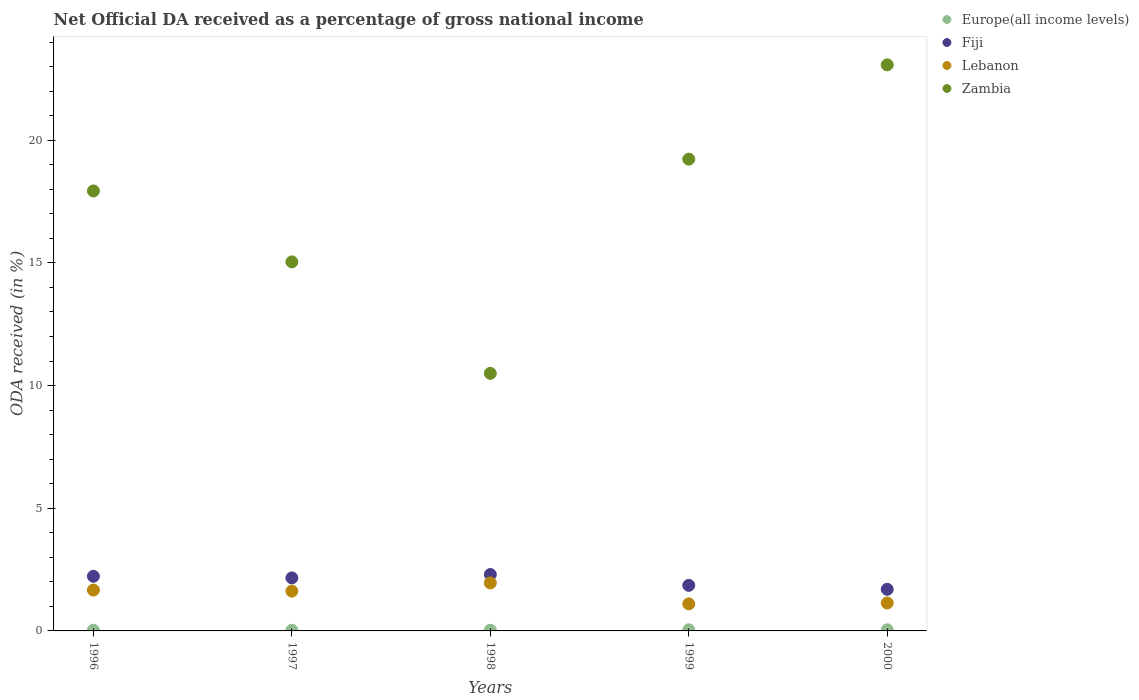How many different coloured dotlines are there?
Your answer should be very brief. 4. Is the number of dotlines equal to the number of legend labels?
Keep it short and to the point. Yes. What is the net official DA received in Fiji in 1999?
Offer a very short reply. 1.86. Across all years, what is the maximum net official DA received in Fiji?
Provide a short and direct response. 2.3. Across all years, what is the minimum net official DA received in Zambia?
Make the answer very short. 10.5. In which year was the net official DA received in Fiji maximum?
Ensure brevity in your answer.  1998. In which year was the net official DA received in Lebanon minimum?
Offer a very short reply. 1999. What is the total net official DA received in Europe(all income levels) in the graph?
Your response must be concise. 0.18. What is the difference between the net official DA received in Fiji in 1996 and that in 1997?
Make the answer very short. 0.07. What is the difference between the net official DA received in Fiji in 1998 and the net official DA received in Lebanon in 2000?
Keep it short and to the point. 1.16. What is the average net official DA received in Lebanon per year?
Make the answer very short. 1.5. In the year 1999, what is the difference between the net official DA received in Zambia and net official DA received in Lebanon?
Provide a short and direct response. 18.12. What is the ratio of the net official DA received in Fiji in 1996 to that in 1997?
Offer a very short reply. 1.03. Is the net official DA received in Zambia in 1996 less than that in 1997?
Give a very brief answer. No. Is the difference between the net official DA received in Zambia in 1997 and 2000 greater than the difference between the net official DA received in Lebanon in 1997 and 2000?
Your answer should be very brief. No. What is the difference between the highest and the second highest net official DA received in Fiji?
Provide a succinct answer. 0.07. What is the difference between the highest and the lowest net official DA received in Europe(all income levels)?
Ensure brevity in your answer.  0.02. Is the sum of the net official DA received in Zambia in 1996 and 2000 greater than the maximum net official DA received in Fiji across all years?
Provide a succinct answer. Yes. Is the net official DA received in Lebanon strictly greater than the net official DA received in Europe(all income levels) over the years?
Keep it short and to the point. Yes. Is the net official DA received in Fiji strictly less than the net official DA received in Zambia over the years?
Give a very brief answer. Yes. How many dotlines are there?
Offer a very short reply. 4. How many years are there in the graph?
Offer a terse response. 5. What is the difference between two consecutive major ticks on the Y-axis?
Offer a terse response. 5. Does the graph contain any zero values?
Ensure brevity in your answer.  No. Where does the legend appear in the graph?
Offer a terse response. Top right. How many legend labels are there?
Make the answer very short. 4. What is the title of the graph?
Make the answer very short. Net Official DA received as a percentage of gross national income. What is the label or title of the Y-axis?
Your answer should be compact. ODA received (in %). What is the ODA received (in %) of Europe(all income levels) in 1996?
Make the answer very short. 0.03. What is the ODA received (in %) in Fiji in 1996?
Your response must be concise. 2.23. What is the ODA received (in %) of Lebanon in 1996?
Your answer should be compact. 1.67. What is the ODA received (in %) in Zambia in 1996?
Give a very brief answer. 17.93. What is the ODA received (in %) of Europe(all income levels) in 1997?
Ensure brevity in your answer.  0.03. What is the ODA received (in %) of Fiji in 1997?
Provide a succinct answer. 2.16. What is the ODA received (in %) of Lebanon in 1997?
Offer a terse response. 1.62. What is the ODA received (in %) of Zambia in 1997?
Give a very brief answer. 15.04. What is the ODA received (in %) of Europe(all income levels) in 1998?
Ensure brevity in your answer.  0.03. What is the ODA received (in %) in Fiji in 1998?
Your answer should be compact. 2.3. What is the ODA received (in %) in Lebanon in 1998?
Your answer should be very brief. 1.96. What is the ODA received (in %) in Zambia in 1998?
Make the answer very short. 10.5. What is the ODA received (in %) in Europe(all income levels) in 1999?
Your answer should be very brief. 0.05. What is the ODA received (in %) in Fiji in 1999?
Give a very brief answer. 1.86. What is the ODA received (in %) of Lebanon in 1999?
Provide a succinct answer. 1.1. What is the ODA received (in %) in Zambia in 1999?
Your response must be concise. 19.23. What is the ODA received (in %) in Europe(all income levels) in 2000?
Your answer should be very brief. 0.05. What is the ODA received (in %) in Fiji in 2000?
Offer a very short reply. 1.7. What is the ODA received (in %) in Lebanon in 2000?
Ensure brevity in your answer.  1.14. What is the ODA received (in %) of Zambia in 2000?
Provide a short and direct response. 23.07. Across all years, what is the maximum ODA received (in %) of Europe(all income levels)?
Your answer should be very brief. 0.05. Across all years, what is the maximum ODA received (in %) in Fiji?
Provide a short and direct response. 2.3. Across all years, what is the maximum ODA received (in %) in Lebanon?
Provide a short and direct response. 1.96. Across all years, what is the maximum ODA received (in %) in Zambia?
Your answer should be compact. 23.07. Across all years, what is the minimum ODA received (in %) in Europe(all income levels)?
Provide a short and direct response. 0.03. Across all years, what is the minimum ODA received (in %) in Fiji?
Your response must be concise. 1.7. Across all years, what is the minimum ODA received (in %) of Lebanon?
Provide a succinct answer. 1.1. Across all years, what is the minimum ODA received (in %) in Zambia?
Your answer should be very brief. 10.5. What is the total ODA received (in %) in Europe(all income levels) in the graph?
Ensure brevity in your answer.  0.18. What is the total ODA received (in %) of Fiji in the graph?
Provide a short and direct response. 10.24. What is the total ODA received (in %) in Lebanon in the graph?
Your answer should be compact. 7.48. What is the total ODA received (in %) of Zambia in the graph?
Offer a very short reply. 85.76. What is the difference between the ODA received (in %) in Europe(all income levels) in 1996 and that in 1997?
Your response must be concise. 0. What is the difference between the ODA received (in %) of Fiji in 1996 and that in 1997?
Keep it short and to the point. 0.07. What is the difference between the ODA received (in %) in Lebanon in 1996 and that in 1997?
Keep it short and to the point. 0.04. What is the difference between the ODA received (in %) of Zambia in 1996 and that in 1997?
Provide a succinct answer. 2.89. What is the difference between the ODA received (in %) of Europe(all income levels) in 1996 and that in 1998?
Offer a terse response. 0. What is the difference between the ODA received (in %) in Fiji in 1996 and that in 1998?
Your answer should be very brief. -0.07. What is the difference between the ODA received (in %) of Lebanon in 1996 and that in 1998?
Your response must be concise. -0.29. What is the difference between the ODA received (in %) of Zambia in 1996 and that in 1998?
Your answer should be very brief. 7.43. What is the difference between the ODA received (in %) of Europe(all income levels) in 1996 and that in 1999?
Your response must be concise. -0.02. What is the difference between the ODA received (in %) in Fiji in 1996 and that in 1999?
Your response must be concise. 0.37. What is the difference between the ODA received (in %) of Lebanon in 1996 and that in 1999?
Provide a short and direct response. 0.56. What is the difference between the ODA received (in %) in Zambia in 1996 and that in 1999?
Your response must be concise. -1.3. What is the difference between the ODA received (in %) in Europe(all income levels) in 1996 and that in 2000?
Your answer should be very brief. -0.02. What is the difference between the ODA received (in %) of Fiji in 1996 and that in 2000?
Your response must be concise. 0.53. What is the difference between the ODA received (in %) of Lebanon in 1996 and that in 2000?
Provide a short and direct response. 0.53. What is the difference between the ODA received (in %) in Zambia in 1996 and that in 2000?
Provide a short and direct response. -5.14. What is the difference between the ODA received (in %) of Europe(all income levels) in 1997 and that in 1998?
Provide a short and direct response. -0. What is the difference between the ODA received (in %) of Fiji in 1997 and that in 1998?
Keep it short and to the point. -0.14. What is the difference between the ODA received (in %) of Lebanon in 1997 and that in 1998?
Your response must be concise. -0.33. What is the difference between the ODA received (in %) in Zambia in 1997 and that in 1998?
Provide a succinct answer. 4.54. What is the difference between the ODA received (in %) in Europe(all income levels) in 1997 and that in 1999?
Make the answer very short. -0.02. What is the difference between the ODA received (in %) in Fiji in 1997 and that in 1999?
Give a very brief answer. 0.3. What is the difference between the ODA received (in %) of Lebanon in 1997 and that in 1999?
Ensure brevity in your answer.  0.52. What is the difference between the ODA received (in %) in Zambia in 1997 and that in 1999?
Your answer should be very brief. -4.19. What is the difference between the ODA received (in %) in Europe(all income levels) in 1997 and that in 2000?
Your answer should be compact. -0.02. What is the difference between the ODA received (in %) of Fiji in 1997 and that in 2000?
Give a very brief answer. 0.47. What is the difference between the ODA received (in %) in Lebanon in 1997 and that in 2000?
Your response must be concise. 0.48. What is the difference between the ODA received (in %) in Zambia in 1997 and that in 2000?
Your answer should be compact. -8.03. What is the difference between the ODA received (in %) in Europe(all income levels) in 1998 and that in 1999?
Your response must be concise. -0.02. What is the difference between the ODA received (in %) in Fiji in 1998 and that in 1999?
Your response must be concise. 0.44. What is the difference between the ODA received (in %) in Lebanon in 1998 and that in 1999?
Provide a succinct answer. 0.85. What is the difference between the ODA received (in %) in Zambia in 1998 and that in 1999?
Offer a very short reply. -8.73. What is the difference between the ODA received (in %) in Europe(all income levels) in 1998 and that in 2000?
Provide a succinct answer. -0.02. What is the difference between the ODA received (in %) in Fiji in 1998 and that in 2000?
Give a very brief answer. 0.6. What is the difference between the ODA received (in %) in Lebanon in 1998 and that in 2000?
Your answer should be compact. 0.82. What is the difference between the ODA received (in %) in Zambia in 1998 and that in 2000?
Your response must be concise. -12.57. What is the difference between the ODA received (in %) in Europe(all income levels) in 1999 and that in 2000?
Your response must be concise. 0. What is the difference between the ODA received (in %) of Fiji in 1999 and that in 2000?
Provide a short and direct response. 0.16. What is the difference between the ODA received (in %) in Lebanon in 1999 and that in 2000?
Give a very brief answer. -0.04. What is the difference between the ODA received (in %) in Zambia in 1999 and that in 2000?
Make the answer very short. -3.84. What is the difference between the ODA received (in %) in Europe(all income levels) in 1996 and the ODA received (in %) in Fiji in 1997?
Your answer should be compact. -2.13. What is the difference between the ODA received (in %) of Europe(all income levels) in 1996 and the ODA received (in %) of Lebanon in 1997?
Offer a very short reply. -1.59. What is the difference between the ODA received (in %) of Europe(all income levels) in 1996 and the ODA received (in %) of Zambia in 1997?
Offer a terse response. -15.01. What is the difference between the ODA received (in %) in Fiji in 1996 and the ODA received (in %) in Lebanon in 1997?
Your answer should be very brief. 0.61. What is the difference between the ODA received (in %) of Fiji in 1996 and the ODA received (in %) of Zambia in 1997?
Your response must be concise. -12.81. What is the difference between the ODA received (in %) of Lebanon in 1996 and the ODA received (in %) of Zambia in 1997?
Your answer should be compact. -13.38. What is the difference between the ODA received (in %) of Europe(all income levels) in 1996 and the ODA received (in %) of Fiji in 1998?
Offer a terse response. -2.27. What is the difference between the ODA received (in %) in Europe(all income levels) in 1996 and the ODA received (in %) in Lebanon in 1998?
Provide a succinct answer. -1.92. What is the difference between the ODA received (in %) of Europe(all income levels) in 1996 and the ODA received (in %) of Zambia in 1998?
Your response must be concise. -10.47. What is the difference between the ODA received (in %) of Fiji in 1996 and the ODA received (in %) of Lebanon in 1998?
Offer a very short reply. 0.27. What is the difference between the ODA received (in %) in Fiji in 1996 and the ODA received (in %) in Zambia in 1998?
Keep it short and to the point. -8.27. What is the difference between the ODA received (in %) in Lebanon in 1996 and the ODA received (in %) in Zambia in 1998?
Your answer should be very brief. -8.83. What is the difference between the ODA received (in %) in Europe(all income levels) in 1996 and the ODA received (in %) in Fiji in 1999?
Keep it short and to the point. -1.83. What is the difference between the ODA received (in %) in Europe(all income levels) in 1996 and the ODA received (in %) in Lebanon in 1999?
Offer a terse response. -1.07. What is the difference between the ODA received (in %) in Europe(all income levels) in 1996 and the ODA received (in %) in Zambia in 1999?
Keep it short and to the point. -19.2. What is the difference between the ODA received (in %) of Fiji in 1996 and the ODA received (in %) of Lebanon in 1999?
Your answer should be compact. 1.12. What is the difference between the ODA received (in %) of Fiji in 1996 and the ODA received (in %) of Zambia in 1999?
Offer a very short reply. -17. What is the difference between the ODA received (in %) of Lebanon in 1996 and the ODA received (in %) of Zambia in 1999?
Offer a very short reply. -17.56. What is the difference between the ODA received (in %) in Europe(all income levels) in 1996 and the ODA received (in %) in Fiji in 2000?
Offer a very short reply. -1.66. What is the difference between the ODA received (in %) of Europe(all income levels) in 1996 and the ODA received (in %) of Lebanon in 2000?
Offer a very short reply. -1.11. What is the difference between the ODA received (in %) of Europe(all income levels) in 1996 and the ODA received (in %) of Zambia in 2000?
Provide a short and direct response. -23.04. What is the difference between the ODA received (in %) in Fiji in 1996 and the ODA received (in %) in Lebanon in 2000?
Your answer should be very brief. 1.09. What is the difference between the ODA received (in %) in Fiji in 1996 and the ODA received (in %) in Zambia in 2000?
Ensure brevity in your answer.  -20.84. What is the difference between the ODA received (in %) of Lebanon in 1996 and the ODA received (in %) of Zambia in 2000?
Your answer should be compact. -21.4. What is the difference between the ODA received (in %) in Europe(all income levels) in 1997 and the ODA received (in %) in Fiji in 1998?
Your answer should be very brief. -2.27. What is the difference between the ODA received (in %) in Europe(all income levels) in 1997 and the ODA received (in %) in Lebanon in 1998?
Your answer should be compact. -1.93. What is the difference between the ODA received (in %) in Europe(all income levels) in 1997 and the ODA received (in %) in Zambia in 1998?
Offer a very short reply. -10.47. What is the difference between the ODA received (in %) in Fiji in 1997 and the ODA received (in %) in Lebanon in 1998?
Your answer should be compact. 0.21. What is the difference between the ODA received (in %) of Fiji in 1997 and the ODA received (in %) of Zambia in 1998?
Give a very brief answer. -8.34. What is the difference between the ODA received (in %) in Lebanon in 1997 and the ODA received (in %) in Zambia in 1998?
Offer a terse response. -8.88. What is the difference between the ODA received (in %) of Europe(all income levels) in 1997 and the ODA received (in %) of Fiji in 1999?
Your answer should be compact. -1.83. What is the difference between the ODA received (in %) of Europe(all income levels) in 1997 and the ODA received (in %) of Lebanon in 1999?
Give a very brief answer. -1.07. What is the difference between the ODA received (in %) in Europe(all income levels) in 1997 and the ODA received (in %) in Zambia in 1999?
Keep it short and to the point. -19.2. What is the difference between the ODA received (in %) of Fiji in 1997 and the ODA received (in %) of Lebanon in 1999?
Keep it short and to the point. 1.06. What is the difference between the ODA received (in %) of Fiji in 1997 and the ODA received (in %) of Zambia in 1999?
Give a very brief answer. -17.07. What is the difference between the ODA received (in %) in Lebanon in 1997 and the ODA received (in %) in Zambia in 1999?
Provide a short and direct response. -17.61. What is the difference between the ODA received (in %) of Europe(all income levels) in 1997 and the ODA received (in %) of Fiji in 2000?
Offer a terse response. -1.67. What is the difference between the ODA received (in %) in Europe(all income levels) in 1997 and the ODA received (in %) in Lebanon in 2000?
Provide a succinct answer. -1.11. What is the difference between the ODA received (in %) of Europe(all income levels) in 1997 and the ODA received (in %) of Zambia in 2000?
Provide a short and direct response. -23.04. What is the difference between the ODA received (in %) of Fiji in 1997 and the ODA received (in %) of Lebanon in 2000?
Your response must be concise. 1.02. What is the difference between the ODA received (in %) in Fiji in 1997 and the ODA received (in %) in Zambia in 2000?
Provide a short and direct response. -20.91. What is the difference between the ODA received (in %) in Lebanon in 1997 and the ODA received (in %) in Zambia in 2000?
Your answer should be very brief. -21.45. What is the difference between the ODA received (in %) of Europe(all income levels) in 1998 and the ODA received (in %) of Fiji in 1999?
Your answer should be very brief. -1.83. What is the difference between the ODA received (in %) of Europe(all income levels) in 1998 and the ODA received (in %) of Lebanon in 1999?
Provide a succinct answer. -1.07. What is the difference between the ODA received (in %) of Europe(all income levels) in 1998 and the ODA received (in %) of Zambia in 1999?
Keep it short and to the point. -19.2. What is the difference between the ODA received (in %) in Fiji in 1998 and the ODA received (in %) in Lebanon in 1999?
Your answer should be compact. 1.2. What is the difference between the ODA received (in %) in Fiji in 1998 and the ODA received (in %) in Zambia in 1999?
Your response must be concise. -16.93. What is the difference between the ODA received (in %) in Lebanon in 1998 and the ODA received (in %) in Zambia in 1999?
Offer a terse response. -17.27. What is the difference between the ODA received (in %) in Europe(all income levels) in 1998 and the ODA received (in %) in Fiji in 2000?
Offer a terse response. -1.67. What is the difference between the ODA received (in %) of Europe(all income levels) in 1998 and the ODA received (in %) of Lebanon in 2000?
Keep it short and to the point. -1.11. What is the difference between the ODA received (in %) in Europe(all income levels) in 1998 and the ODA received (in %) in Zambia in 2000?
Give a very brief answer. -23.04. What is the difference between the ODA received (in %) of Fiji in 1998 and the ODA received (in %) of Lebanon in 2000?
Offer a terse response. 1.16. What is the difference between the ODA received (in %) in Fiji in 1998 and the ODA received (in %) in Zambia in 2000?
Make the answer very short. -20.77. What is the difference between the ODA received (in %) in Lebanon in 1998 and the ODA received (in %) in Zambia in 2000?
Offer a terse response. -21.11. What is the difference between the ODA received (in %) in Europe(all income levels) in 1999 and the ODA received (in %) in Fiji in 2000?
Provide a succinct answer. -1.65. What is the difference between the ODA received (in %) of Europe(all income levels) in 1999 and the ODA received (in %) of Lebanon in 2000?
Offer a very short reply. -1.09. What is the difference between the ODA received (in %) of Europe(all income levels) in 1999 and the ODA received (in %) of Zambia in 2000?
Offer a terse response. -23.02. What is the difference between the ODA received (in %) in Fiji in 1999 and the ODA received (in %) in Lebanon in 2000?
Give a very brief answer. 0.72. What is the difference between the ODA received (in %) of Fiji in 1999 and the ODA received (in %) of Zambia in 2000?
Give a very brief answer. -21.21. What is the difference between the ODA received (in %) of Lebanon in 1999 and the ODA received (in %) of Zambia in 2000?
Provide a short and direct response. -21.97. What is the average ODA received (in %) of Europe(all income levels) per year?
Keep it short and to the point. 0.04. What is the average ODA received (in %) in Fiji per year?
Make the answer very short. 2.05. What is the average ODA received (in %) of Lebanon per year?
Offer a very short reply. 1.5. What is the average ODA received (in %) of Zambia per year?
Your answer should be compact. 17.15. In the year 1996, what is the difference between the ODA received (in %) in Europe(all income levels) and ODA received (in %) in Fiji?
Provide a short and direct response. -2.2. In the year 1996, what is the difference between the ODA received (in %) of Europe(all income levels) and ODA received (in %) of Lebanon?
Make the answer very short. -1.63. In the year 1996, what is the difference between the ODA received (in %) in Europe(all income levels) and ODA received (in %) in Zambia?
Ensure brevity in your answer.  -17.9. In the year 1996, what is the difference between the ODA received (in %) of Fiji and ODA received (in %) of Lebanon?
Provide a succinct answer. 0.56. In the year 1996, what is the difference between the ODA received (in %) of Fiji and ODA received (in %) of Zambia?
Offer a terse response. -15.7. In the year 1996, what is the difference between the ODA received (in %) of Lebanon and ODA received (in %) of Zambia?
Provide a short and direct response. -16.27. In the year 1997, what is the difference between the ODA received (in %) in Europe(all income levels) and ODA received (in %) in Fiji?
Your response must be concise. -2.13. In the year 1997, what is the difference between the ODA received (in %) in Europe(all income levels) and ODA received (in %) in Lebanon?
Your answer should be very brief. -1.59. In the year 1997, what is the difference between the ODA received (in %) in Europe(all income levels) and ODA received (in %) in Zambia?
Give a very brief answer. -15.01. In the year 1997, what is the difference between the ODA received (in %) in Fiji and ODA received (in %) in Lebanon?
Make the answer very short. 0.54. In the year 1997, what is the difference between the ODA received (in %) in Fiji and ODA received (in %) in Zambia?
Provide a short and direct response. -12.88. In the year 1997, what is the difference between the ODA received (in %) of Lebanon and ODA received (in %) of Zambia?
Give a very brief answer. -13.42. In the year 1998, what is the difference between the ODA received (in %) in Europe(all income levels) and ODA received (in %) in Fiji?
Keep it short and to the point. -2.27. In the year 1998, what is the difference between the ODA received (in %) of Europe(all income levels) and ODA received (in %) of Lebanon?
Your answer should be compact. -1.93. In the year 1998, what is the difference between the ODA received (in %) in Europe(all income levels) and ODA received (in %) in Zambia?
Your answer should be compact. -10.47. In the year 1998, what is the difference between the ODA received (in %) of Fiji and ODA received (in %) of Lebanon?
Offer a very short reply. 0.34. In the year 1998, what is the difference between the ODA received (in %) in Fiji and ODA received (in %) in Zambia?
Offer a very short reply. -8.2. In the year 1998, what is the difference between the ODA received (in %) of Lebanon and ODA received (in %) of Zambia?
Make the answer very short. -8.54. In the year 1999, what is the difference between the ODA received (in %) in Europe(all income levels) and ODA received (in %) in Fiji?
Provide a succinct answer. -1.81. In the year 1999, what is the difference between the ODA received (in %) of Europe(all income levels) and ODA received (in %) of Lebanon?
Keep it short and to the point. -1.06. In the year 1999, what is the difference between the ODA received (in %) of Europe(all income levels) and ODA received (in %) of Zambia?
Your response must be concise. -19.18. In the year 1999, what is the difference between the ODA received (in %) of Fiji and ODA received (in %) of Lebanon?
Your answer should be compact. 0.76. In the year 1999, what is the difference between the ODA received (in %) in Fiji and ODA received (in %) in Zambia?
Your answer should be compact. -17.37. In the year 1999, what is the difference between the ODA received (in %) of Lebanon and ODA received (in %) of Zambia?
Provide a succinct answer. -18.12. In the year 2000, what is the difference between the ODA received (in %) of Europe(all income levels) and ODA received (in %) of Fiji?
Make the answer very short. -1.65. In the year 2000, what is the difference between the ODA received (in %) of Europe(all income levels) and ODA received (in %) of Lebanon?
Your response must be concise. -1.09. In the year 2000, what is the difference between the ODA received (in %) in Europe(all income levels) and ODA received (in %) in Zambia?
Offer a terse response. -23.02. In the year 2000, what is the difference between the ODA received (in %) in Fiji and ODA received (in %) in Lebanon?
Your answer should be very brief. 0.56. In the year 2000, what is the difference between the ODA received (in %) of Fiji and ODA received (in %) of Zambia?
Your response must be concise. -21.37. In the year 2000, what is the difference between the ODA received (in %) in Lebanon and ODA received (in %) in Zambia?
Make the answer very short. -21.93. What is the ratio of the ODA received (in %) of Europe(all income levels) in 1996 to that in 1997?
Ensure brevity in your answer.  1.14. What is the ratio of the ODA received (in %) in Fiji in 1996 to that in 1997?
Your response must be concise. 1.03. What is the ratio of the ODA received (in %) of Lebanon in 1996 to that in 1997?
Provide a succinct answer. 1.03. What is the ratio of the ODA received (in %) of Zambia in 1996 to that in 1997?
Provide a succinct answer. 1.19. What is the ratio of the ODA received (in %) in Europe(all income levels) in 1996 to that in 1998?
Provide a short and direct response. 1.06. What is the ratio of the ODA received (in %) of Fiji in 1996 to that in 1998?
Keep it short and to the point. 0.97. What is the ratio of the ODA received (in %) in Lebanon in 1996 to that in 1998?
Your answer should be very brief. 0.85. What is the ratio of the ODA received (in %) of Zambia in 1996 to that in 1998?
Provide a succinct answer. 1.71. What is the ratio of the ODA received (in %) of Europe(all income levels) in 1996 to that in 1999?
Your response must be concise. 0.67. What is the ratio of the ODA received (in %) in Fiji in 1996 to that in 1999?
Keep it short and to the point. 1.2. What is the ratio of the ODA received (in %) in Lebanon in 1996 to that in 1999?
Ensure brevity in your answer.  1.51. What is the ratio of the ODA received (in %) of Zambia in 1996 to that in 1999?
Your answer should be compact. 0.93. What is the ratio of the ODA received (in %) in Europe(all income levels) in 1996 to that in 2000?
Give a very brief answer. 0.67. What is the ratio of the ODA received (in %) of Fiji in 1996 to that in 2000?
Give a very brief answer. 1.31. What is the ratio of the ODA received (in %) of Lebanon in 1996 to that in 2000?
Ensure brevity in your answer.  1.46. What is the ratio of the ODA received (in %) in Zambia in 1996 to that in 2000?
Give a very brief answer. 0.78. What is the ratio of the ODA received (in %) of Europe(all income levels) in 1997 to that in 1998?
Your answer should be very brief. 0.93. What is the ratio of the ODA received (in %) in Fiji in 1997 to that in 1998?
Your answer should be compact. 0.94. What is the ratio of the ODA received (in %) in Lebanon in 1997 to that in 1998?
Offer a terse response. 0.83. What is the ratio of the ODA received (in %) of Zambia in 1997 to that in 1998?
Give a very brief answer. 1.43. What is the ratio of the ODA received (in %) of Europe(all income levels) in 1997 to that in 1999?
Your answer should be very brief. 0.59. What is the ratio of the ODA received (in %) in Fiji in 1997 to that in 1999?
Make the answer very short. 1.16. What is the ratio of the ODA received (in %) in Lebanon in 1997 to that in 1999?
Make the answer very short. 1.47. What is the ratio of the ODA received (in %) of Zambia in 1997 to that in 1999?
Offer a very short reply. 0.78. What is the ratio of the ODA received (in %) of Europe(all income levels) in 1997 to that in 2000?
Make the answer very short. 0.59. What is the ratio of the ODA received (in %) in Fiji in 1997 to that in 2000?
Offer a terse response. 1.27. What is the ratio of the ODA received (in %) of Lebanon in 1997 to that in 2000?
Your answer should be compact. 1.43. What is the ratio of the ODA received (in %) in Zambia in 1997 to that in 2000?
Offer a terse response. 0.65. What is the ratio of the ODA received (in %) of Europe(all income levels) in 1998 to that in 1999?
Keep it short and to the point. 0.63. What is the ratio of the ODA received (in %) of Fiji in 1998 to that in 1999?
Give a very brief answer. 1.24. What is the ratio of the ODA received (in %) of Lebanon in 1998 to that in 1999?
Your answer should be compact. 1.77. What is the ratio of the ODA received (in %) of Zambia in 1998 to that in 1999?
Your answer should be very brief. 0.55. What is the ratio of the ODA received (in %) of Europe(all income levels) in 1998 to that in 2000?
Your answer should be very brief. 0.63. What is the ratio of the ODA received (in %) of Fiji in 1998 to that in 2000?
Keep it short and to the point. 1.36. What is the ratio of the ODA received (in %) of Lebanon in 1998 to that in 2000?
Give a very brief answer. 1.72. What is the ratio of the ODA received (in %) in Zambia in 1998 to that in 2000?
Your response must be concise. 0.46. What is the ratio of the ODA received (in %) of Europe(all income levels) in 1999 to that in 2000?
Ensure brevity in your answer.  1.01. What is the ratio of the ODA received (in %) in Fiji in 1999 to that in 2000?
Make the answer very short. 1.1. What is the ratio of the ODA received (in %) of Lebanon in 1999 to that in 2000?
Make the answer very short. 0.97. What is the ratio of the ODA received (in %) in Zambia in 1999 to that in 2000?
Give a very brief answer. 0.83. What is the difference between the highest and the second highest ODA received (in %) in Europe(all income levels)?
Ensure brevity in your answer.  0. What is the difference between the highest and the second highest ODA received (in %) in Fiji?
Keep it short and to the point. 0.07. What is the difference between the highest and the second highest ODA received (in %) in Lebanon?
Provide a short and direct response. 0.29. What is the difference between the highest and the second highest ODA received (in %) in Zambia?
Your answer should be very brief. 3.84. What is the difference between the highest and the lowest ODA received (in %) of Europe(all income levels)?
Your answer should be very brief. 0.02. What is the difference between the highest and the lowest ODA received (in %) in Fiji?
Give a very brief answer. 0.6. What is the difference between the highest and the lowest ODA received (in %) in Lebanon?
Offer a terse response. 0.85. What is the difference between the highest and the lowest ODA received (in %) in Zambia?
Your answer should be very brief. 12.57. 